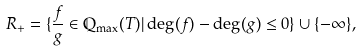Convert formula to latex. <formula><loc_0><loc_0><loc_500><loc_500>R _ { + } = \{ \frac { f } { g } \in \mathbb { Q } _ { \max } ( T ) | \deg ( f ) - \deg ( g ) \leq 0 \} \cup \{ - \infty \} ,</formula> 